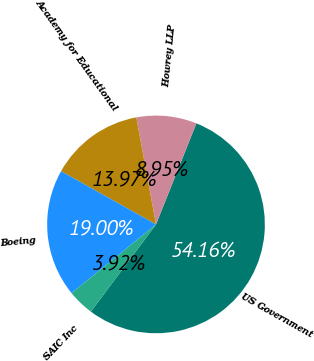<chart> <loc_0><loc_0><loc_500><loc_500><pie_chart><fcel>US Government<fcel>Howrey LLP<fcel>Academy for Educational<fcel>Boeing<fcel>SAIC Inc<nl><fcel>54.16%<fcel>8.95%<fcel>13.97%<fcel>19.0%<fcel>3.92%<nl></chart> 